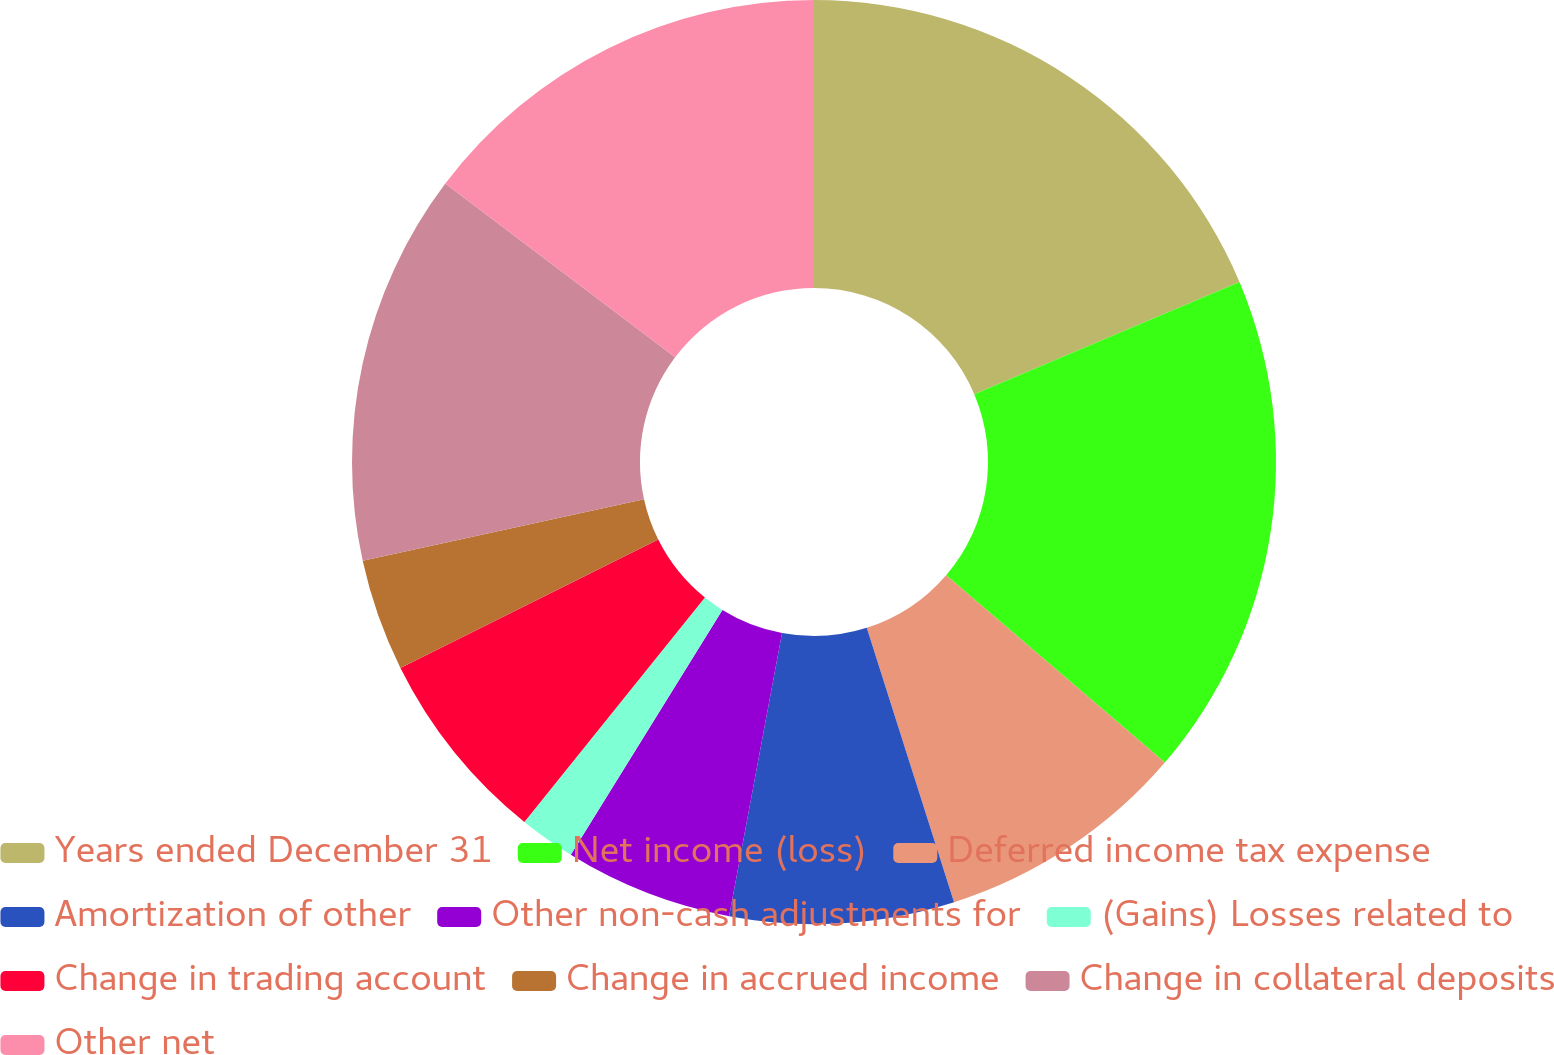Convert chart. <chart><loc_0><loc_0><loc_500><loc_500><pie_chart><fcel>Years ended December 31<fcel>Net income (loss)<fcel>Deferred income tax expense<fcel>Amortization of other<fcel>Other non-cash adjustments for<fcel>(Gains) Losses related to<fcel>Change in trading account<fcel>Change in accrued income<fcel>Change in collateral deposits<fcel>Other net<nl><fcel>18.62%<fcel>17.64%<fcel>8.82%<fcel>7.84%<fcel>5.88%<fcel>1.96%<fcel>6.86%<fcel>3.92%<fcel>13.72%<fcel>14.7%<nl></chart> 